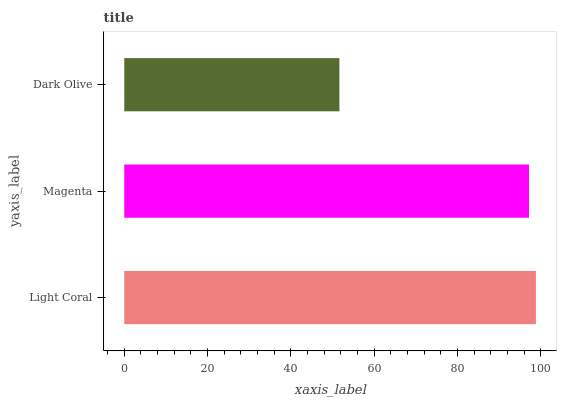Is Dark Olive the minimum?
Answer yes or no. Yes. Is Light Coral the maximum?
Answer yes or no. Yes. Is Magenta the minimum?
Answer yes or no. No. Is Magenta the maximum?
Answer yes or no. No. Is Light Coral greater than Magenta?
Answer yes or no. Yes. Is Magenta less than Light Coral?
Answer yes or no. Yes. Is Magenta greater than Light Coral?
Answer yes or no. No. Is Light Coral less than Magenta?
Answer yes or no. No. Is Magenta the high median?
Answer yes or no. Yes. Is Magenta the low median?
Answer yes or no. Yes. Is Dark Olive the high median?
Answer yes or no. No. Is Light Coral the low median?
Answer yes or no. No. 